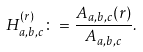<formula> <loc_0><loc_0><loc_500><loc_500>H _ { a , b , c } ^ { ( r ) } \colon = \frac { A _ { a , b , c } ( r ) } { A _ { a , b , c } } .</formula> 